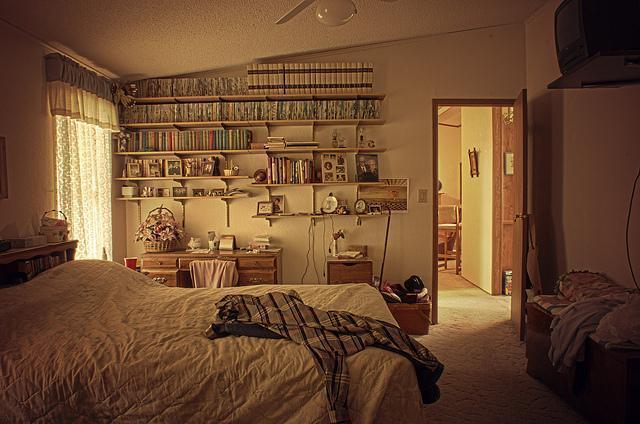How many pillows are on the bed?
Give a very brief answer. 2. How many tvs are visible?
Give a very brief answer. 1. How many white cats are there in the image?
Give a very brief answer. 0. 